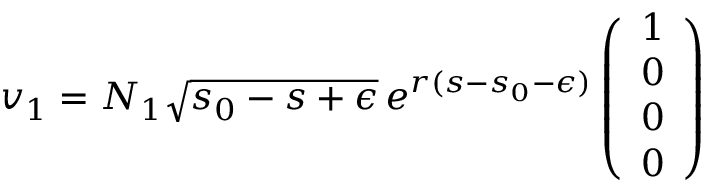Convert formula to latex. <formula><loc_0><loc_0><loc_500><loc_500>v _ { 1 } = N _ { 1 } \sqrt { s _ { 0 } - s + \epsilon } \, e ^ { r ( s - s _ { 0 } - \epsilon ) } \left ( \begin{array} { c } { 1 } \\ { 0 } \\ { 0 } \\ { 0 } \end{array} \right )</formula> 